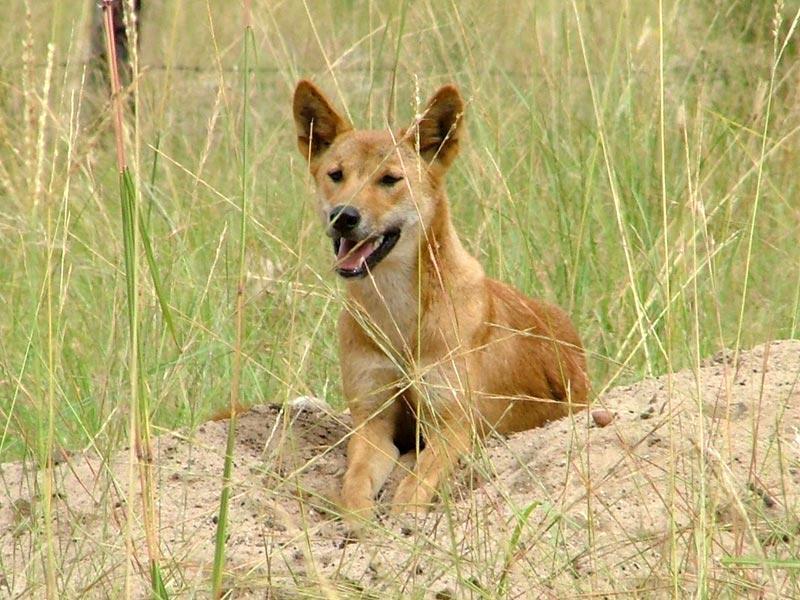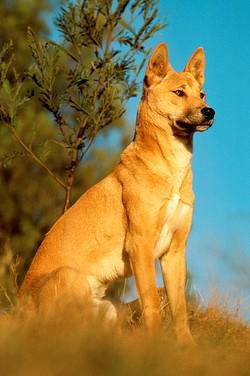The first image is the image on the left, the second image is the image on the right. For the images shown, is this caption "The dog in the image on the left is lying with its mouth open." true? Answer yes or no. Yes. 